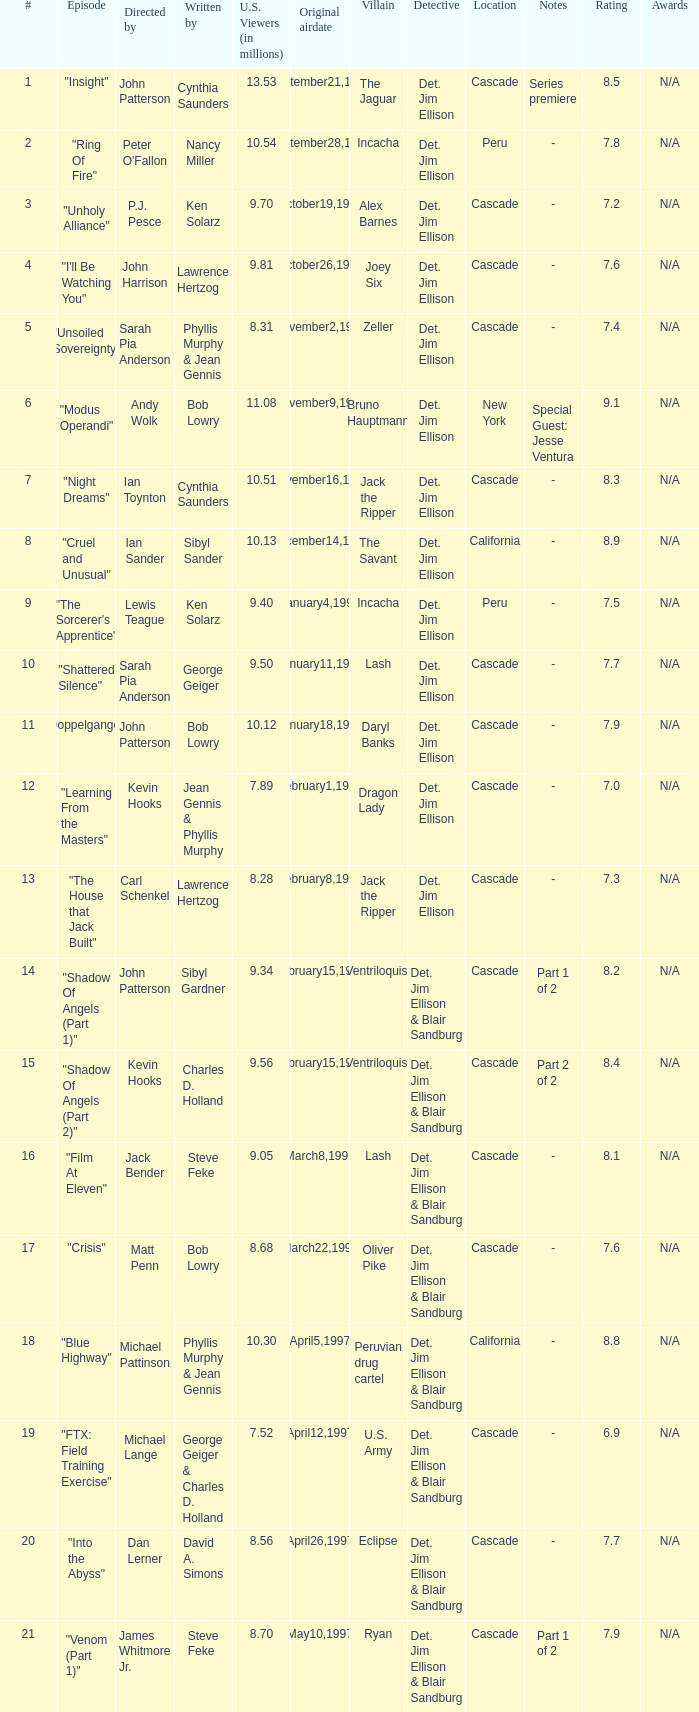Who wrote the episode with 7.52 million US viewers? George Geiger & Charles D. Holland. 